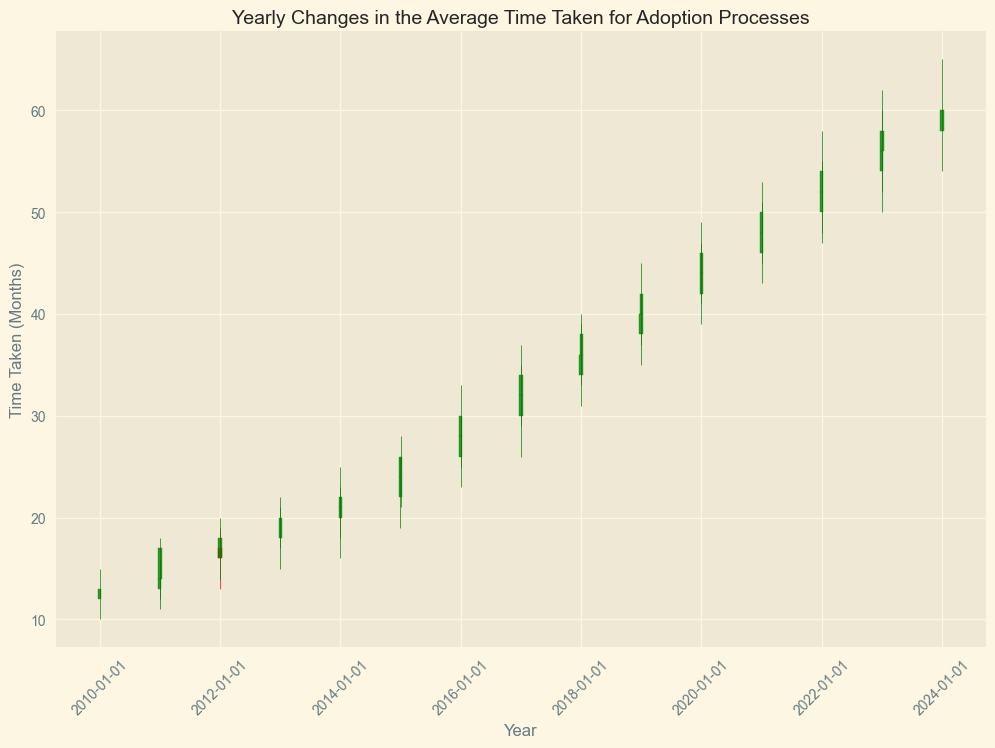What is the general trend of the average time taken for adoption processes from 2010 to 2023? To determine the general trend, observe the overall progression of the candlesticks from 2010 to 2023. The lows and highs progressively increase, indicating a rising trend in the average time taken.
Answer: Increasing Between 2010 and 2023, which year showed the highest peak in the average time taken for adoption processes? Look for the point where the highest part of the candlestick (the wick) touches its maximum value. In 2023, the high reaches up to 65, which is the highest peak across all years.
Answer: 2023 How did the average time taken change from the beginning to the end of 2013? Check the prices at the open (start) and close (end) positions in 2013. At the beginning of 2013, the value is 19, and at the end, it is 21. Thus, it increased by 2 units.
Answer: Increased by 2 units Which year experienced the largest range (difference between high and low) in the average time taken for adoption processes? Calculate the range for each year by subtracting the low from the high and find the year with the largest range. For 2016, subtracting 26 from 35 gives a range of 9, which is the largest range observed.
Answer: 2016 Was there any year where the average time taken for adoptions decreased when compared to the previous year? If yes, which year? Examine the end value (close) of each year and compare it to the start value (open) of the next year. The year 2011 closed at 16, and 2012 opened at 16, indicating no decrease. Every subsequent year shows an increase, meaning no year had a decrease.
Answer: No Comparing 2015 and 2020, which year had a higher low point in the average time taken for adoption processes? Compare the lowest points of both years by looking at the position of the bottom wick. In 2020, the low is 43, whereas in 2015, it is 21. Therefore, 2020 has a higher low point.
Answer: 2020 What is the median closing value of the average time taken for the adoption processes from 2010 to 2023? List the closing values: (14, 16, 19, 21, 24, 28, 32, 36, 40, 44, 48, 52, 56, 60). The median is the middle value of this sorted list. Since there are 14 values, the median is the average of the 7th and 8th values, which is (32+36)/2 = 34.
Answer: 34 Did the average time taken for adoption processes close higher in 2018 than it opened in 2019? Compare the closing value of 2018 (40) with the opening value of 2019 (40). Both values are the same, indicating no change.
Answer: No, it closed equal to what it opened in 2019 